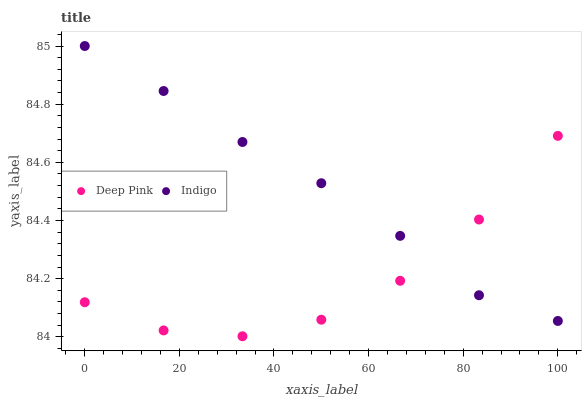Does Deep Pink have the minimum area under the curve?
Answer yes or no. Yes. Does Indigo have the maximum area under the curve?
Answer yes or no. Yes. Does Indigo have the minimum area under the curve?
Answer yes or no. No. Is Indigo the smoothest?
Answer yes or no. Yes. Is Deep Pink the roughest?
Answer yes or no. Yes. Is Indigo the roughest?
Answer yes or no. No. Does Deep Pink have the lowest value?
Answer yes or no. Yes. Does Indigo have the lowest value?
Answer yes or no. No. Does Indigo have the highest value?
Answer yes or no. Yes. Does Indigo intersect Deep Pink?
Answer yes or no. Yes. Is Indigo less than Deep Pink?
Answer yes or no. No. Is Indigo greater than Deep Pink?
Answer yes or no. No. 